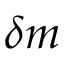Convert formula to latex. <formula><loc_0><loc_0><loc_500><loc_500>\delta m</formula> 